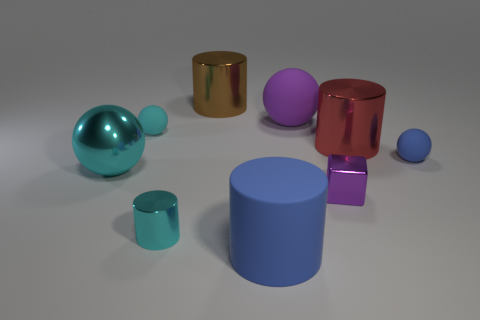What number of shiny things are small blue spheres or small purple cylinders? In the image, I can identify one small blue sphere and two small purple cylinders, making the total count three. 